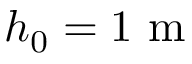Convert formula to latex. <formula><loc_0><loc_0><loc_500><loc_500>h _ { 0 } = 1 m</formula> 